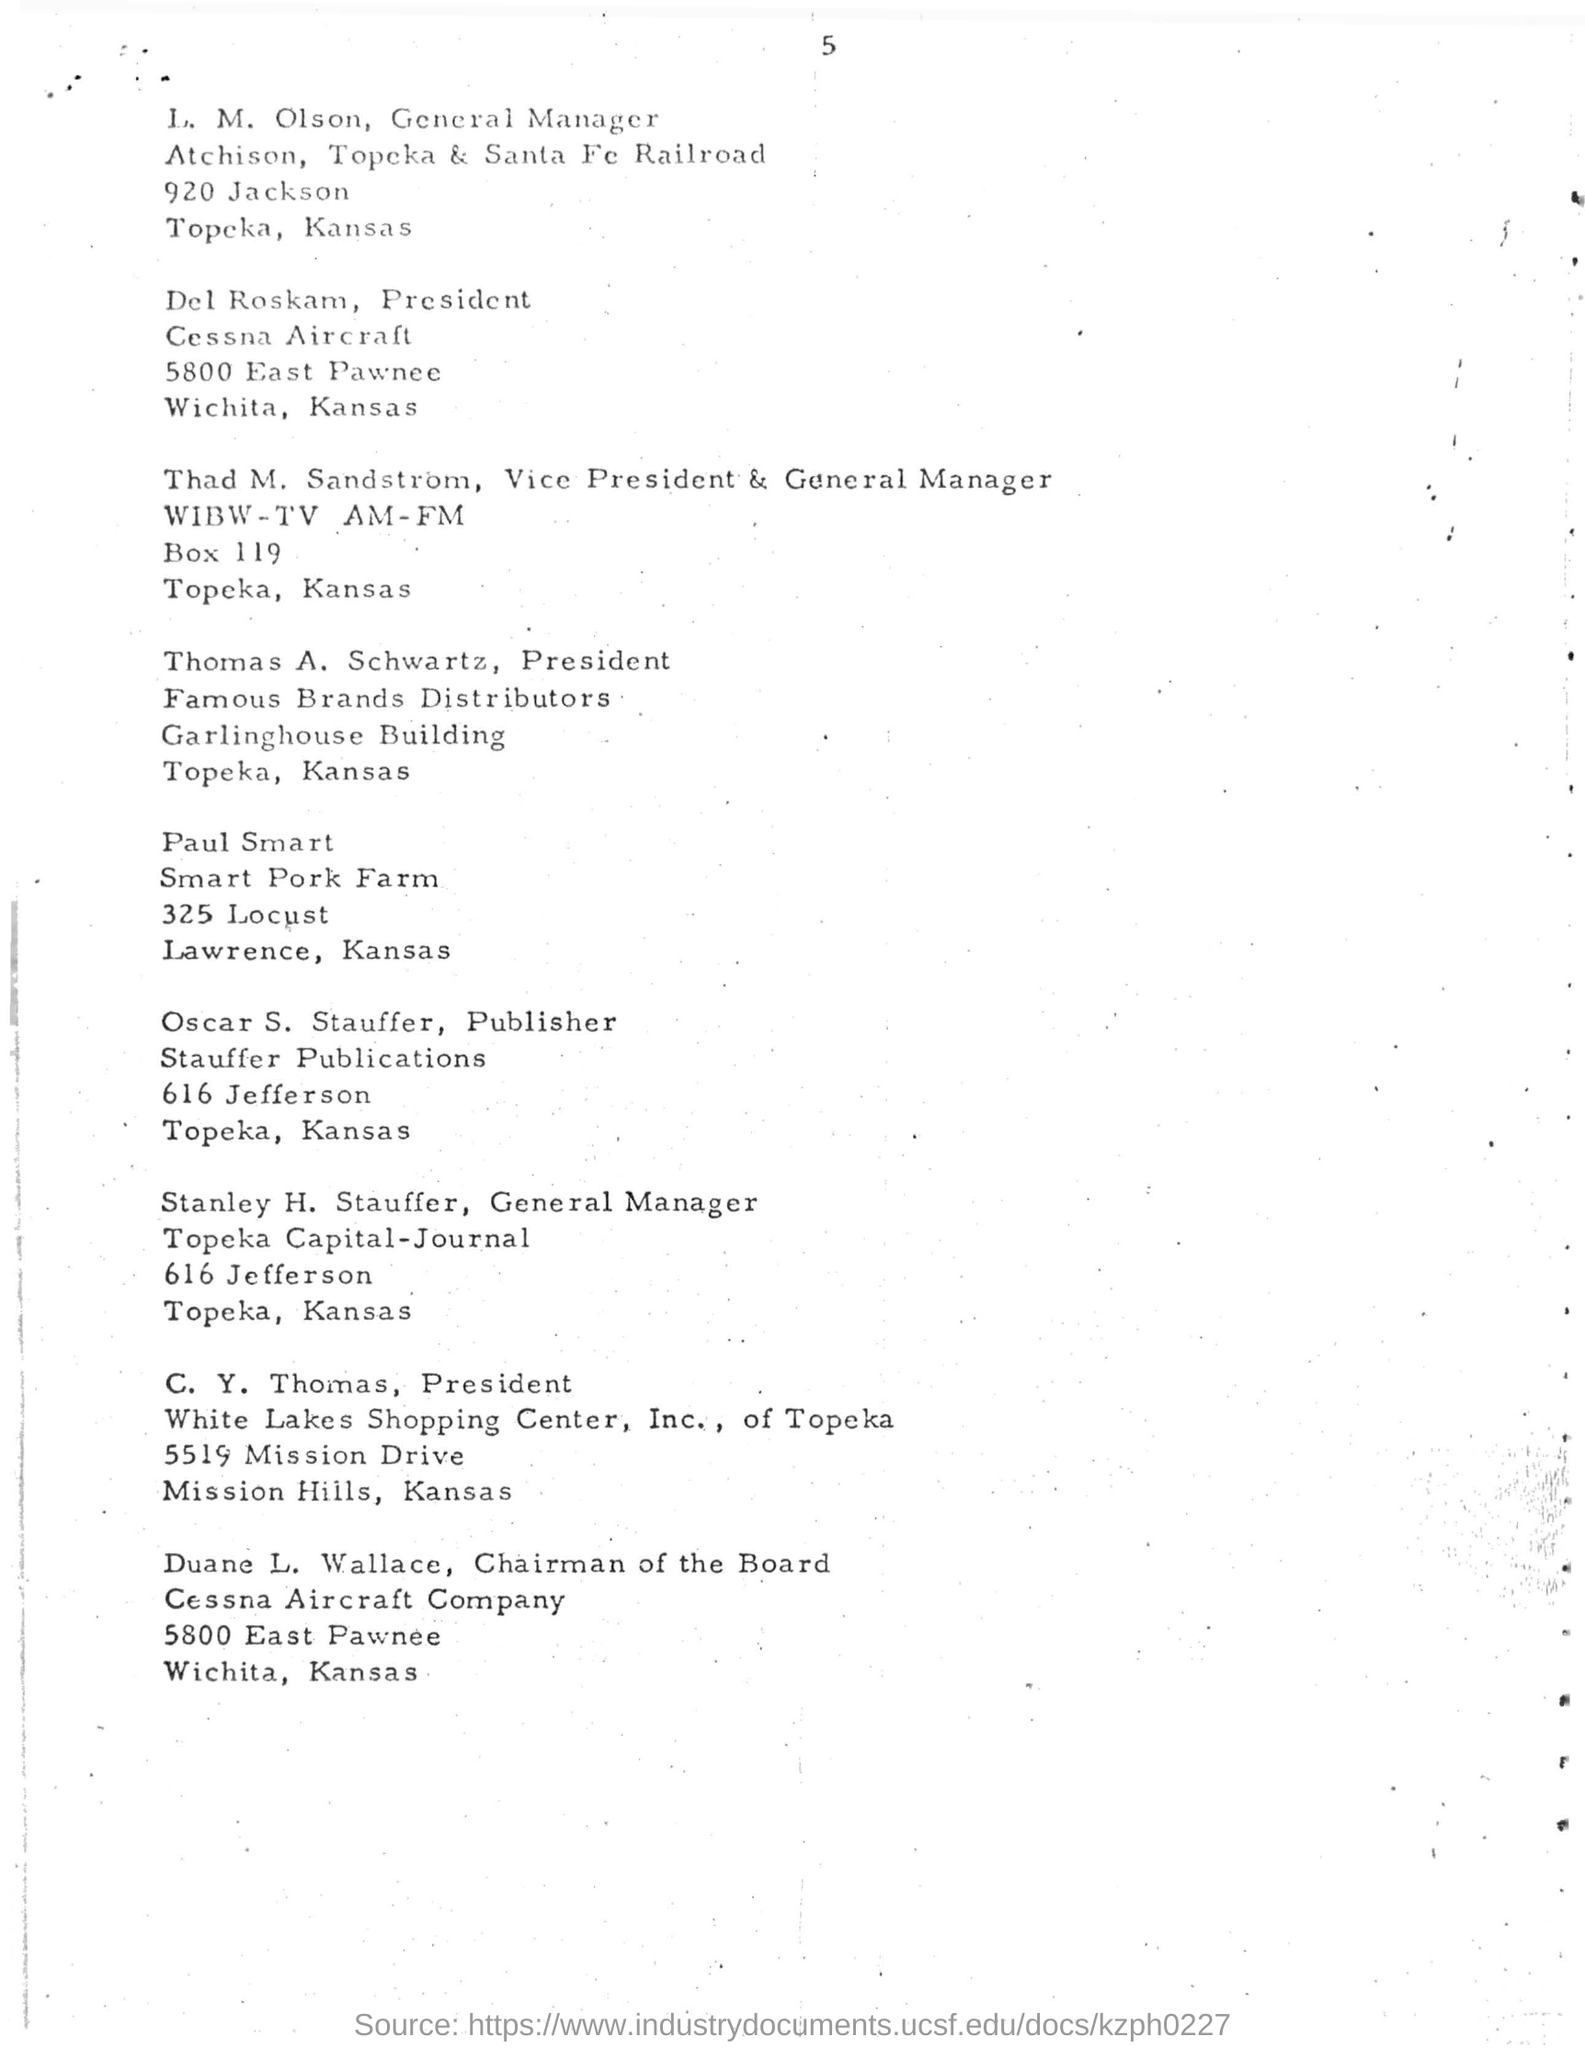What is the name of the publisher mentioned ?
Provide a succinct answer. Oscar S. Stauffer. Who is the general manager of topeka capital-journal ?
Ensure brevity in your answer.  Stanley H. Stauffer. Who is the president of cessna aircraft ?
Offer a terse response. Del Roskam. Who is the president of famous brands distributors ?
Your response must be concise. Thomas A. Schwartz. Who is the president of white lakes shopping center, inc. , of topeka ?
Give a very brief answer. C. Y. Thomas. 